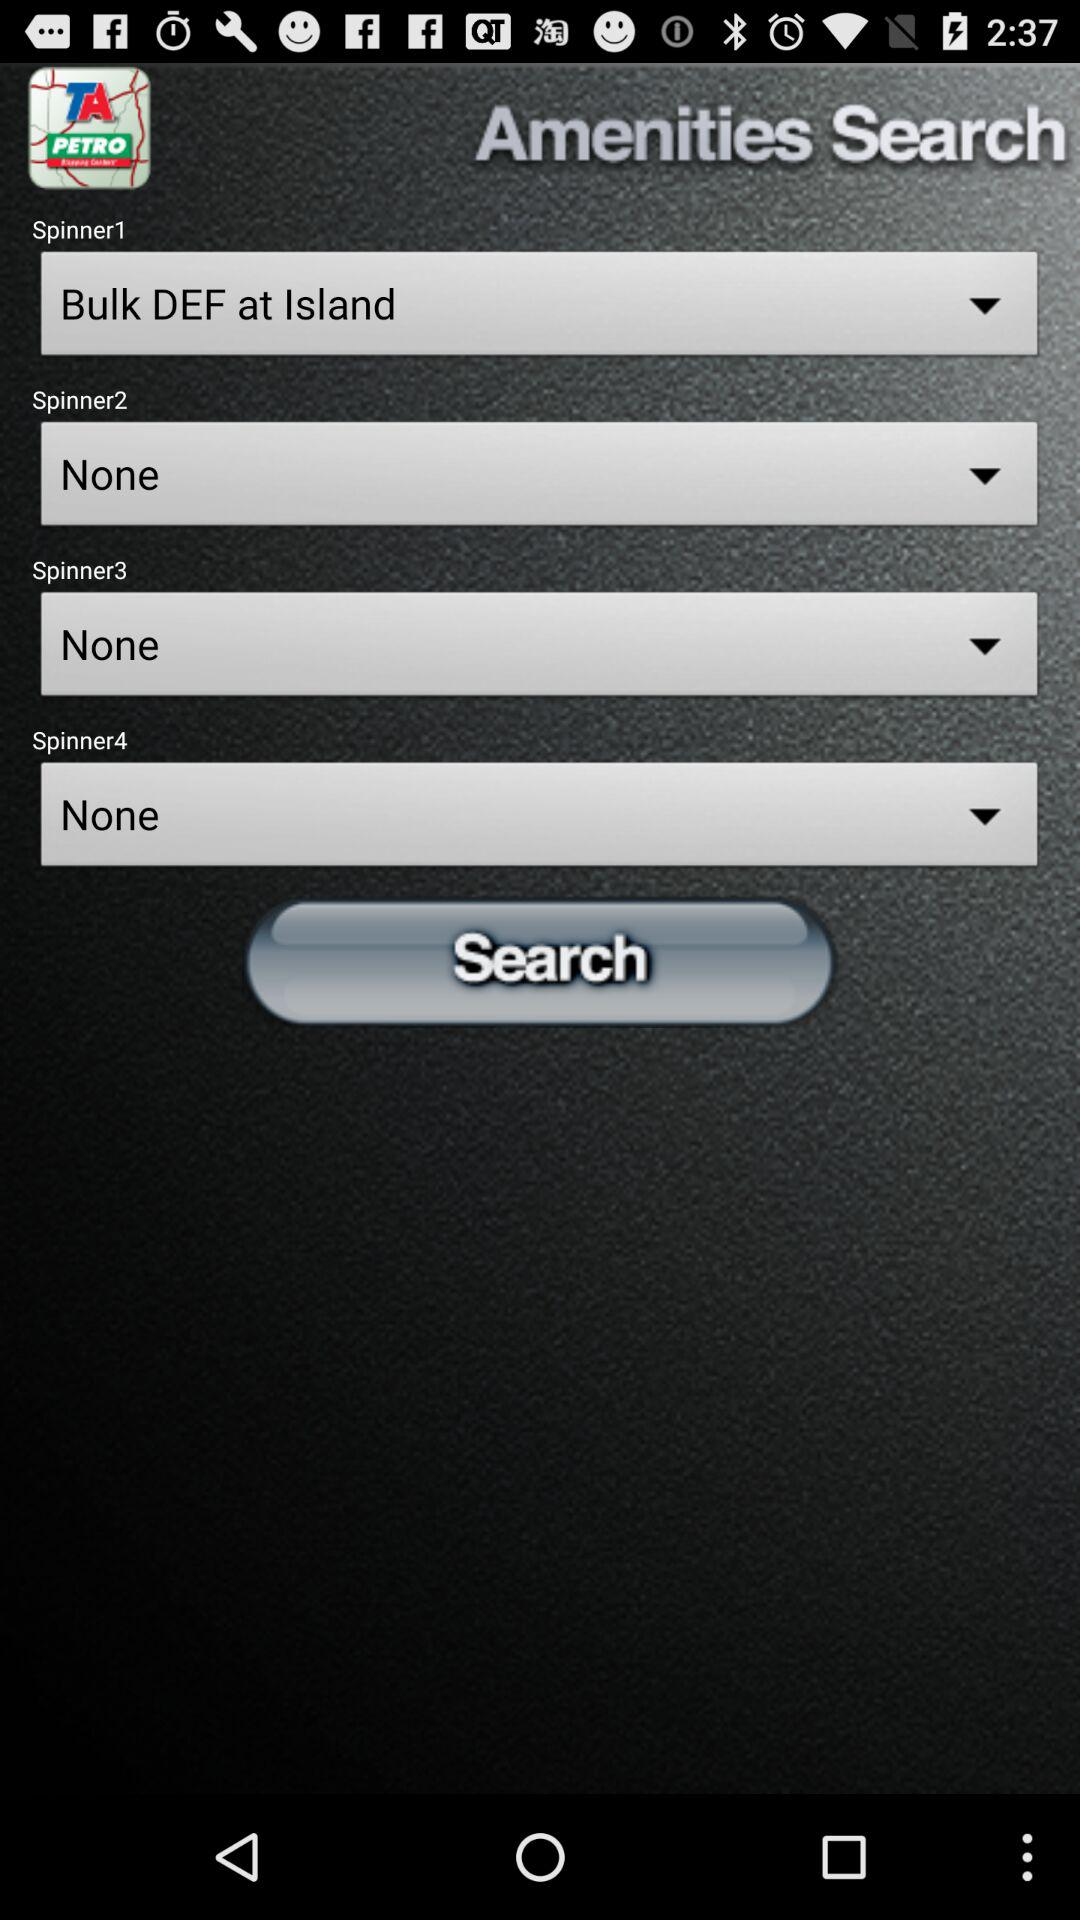What option is selected for "Spinner2"? The selected option for "Spinner2" is "None". 